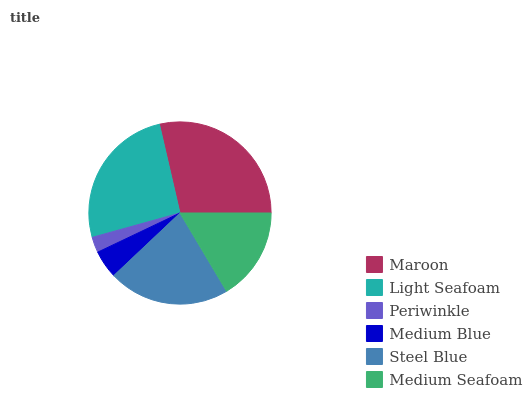Is Periwinkle the minimum?
Answer yes or no. Yes. Is Maroon the maximum?
Answer yes or no. Yes. Is Light Seafoam the minimum?
Answer yes or no. No. Is Light Seafoam the maximum?
Answer yes or no. No. Is Maroon greater than Light Seafoam?
Answer yes or no. Yes. Is Light Seafoam less than Maroon?
Answer yes or no. Yes. Is Light Seafoam greater than Maroon?
Answer yes or no. No. Is Maroon less than Light Seafoam?
Answer yes or no. No. Is Steel Blue the high median?
Answer yes or no. Yes. Is Medium Seafoam the low median?
Answer yes or no. Yes. Is Periwinkle the high median?
Answer yes or no. No. Is Light Seafoam the low median?
Answer yes or no. No. 